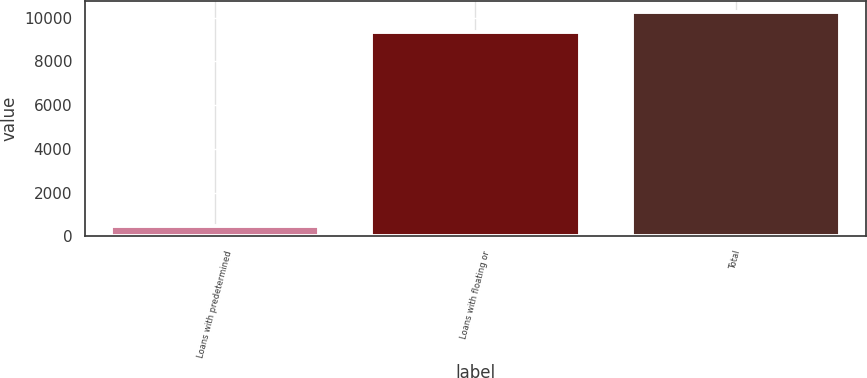<chart> <loc_0><loc_0><loc_500><loc_500><bar_chart><fcel>Loans with predetermined<fcel>Loans with floating or<fcel>Total<nl><fcel>473<fcel>9333<fcel>10266.3<nl></chart> 